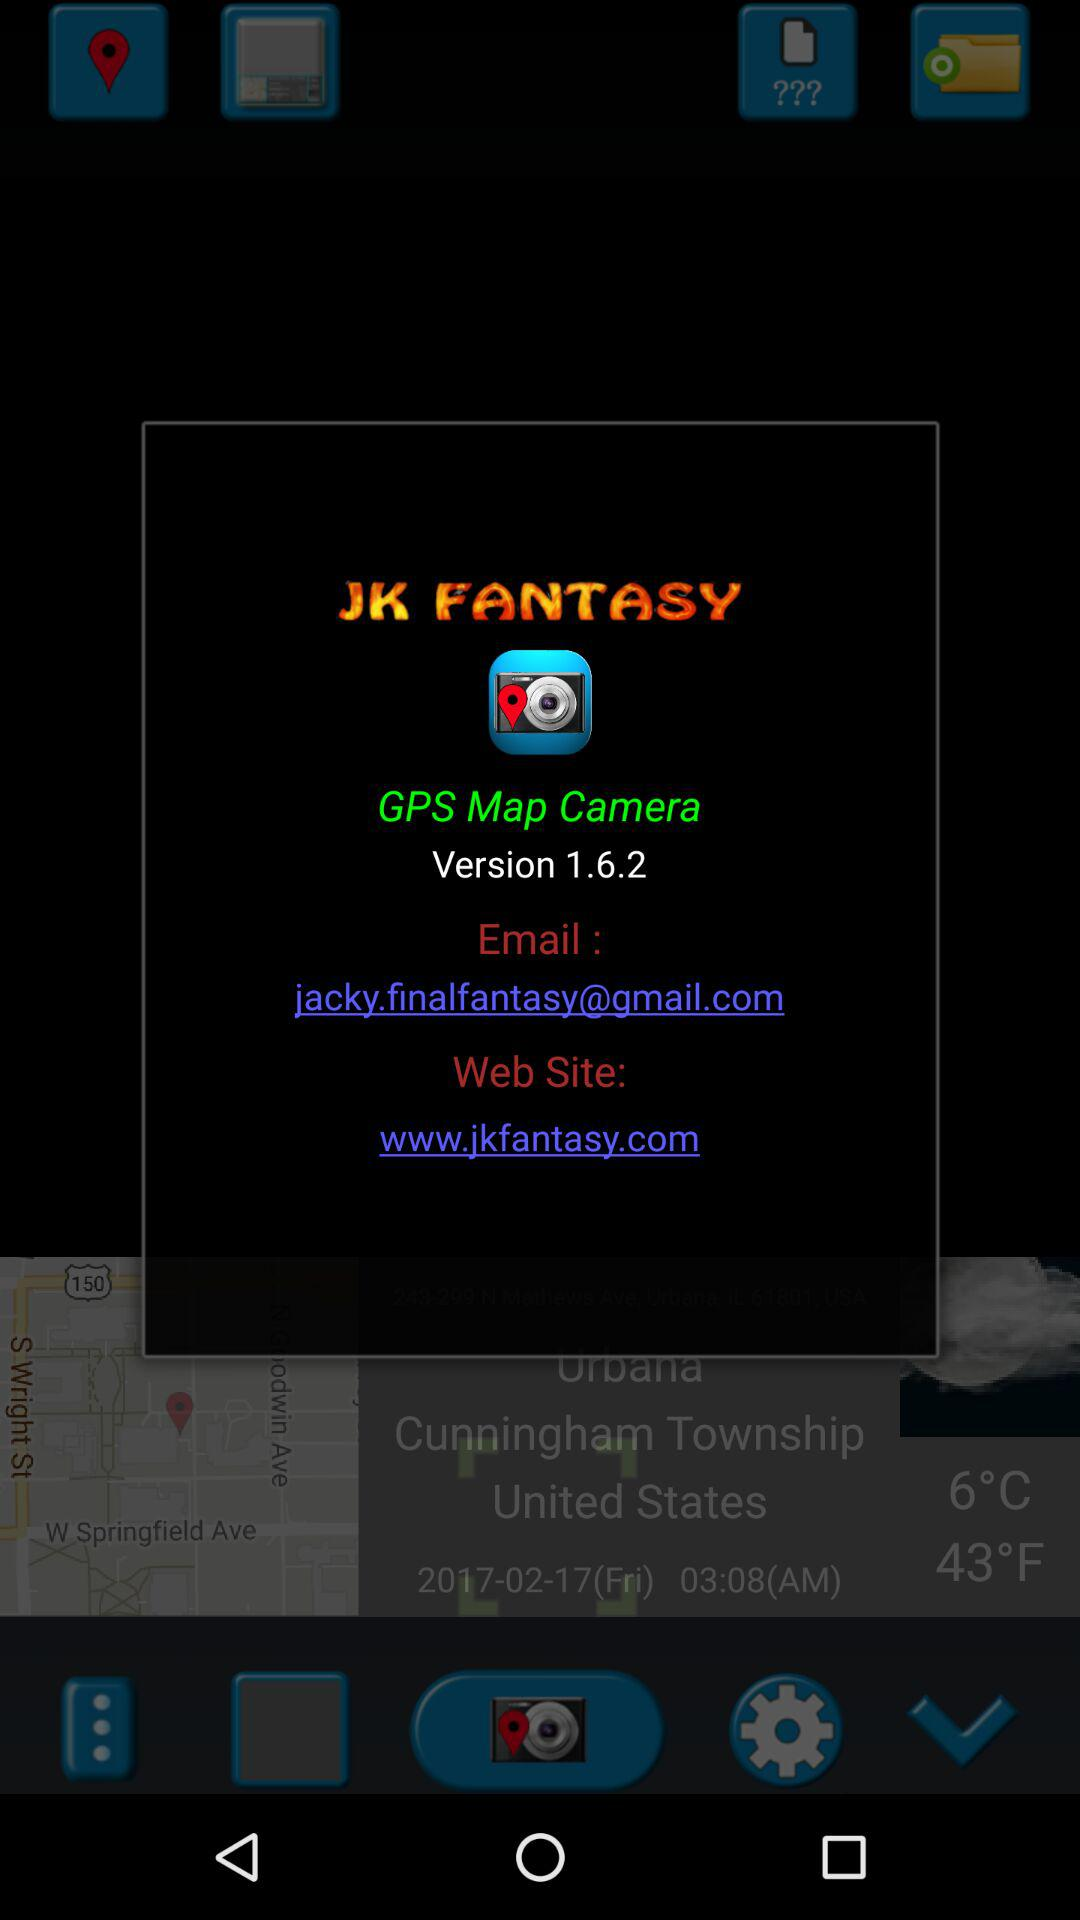What Gmail address is used? The used Gmail address is jacky.finalfantasy@gmail.com. 